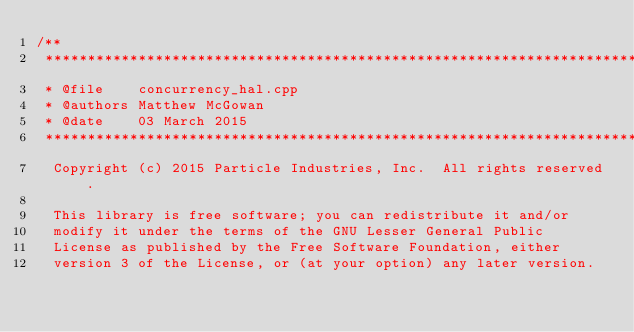<code> <loc_0><loc_0><loc_500><loc_500><_C++_>/**
 ******************************************************************************
 * @file    concurrency_hal.cpp
 * @authors Matthew McGowan
 * @date    03 March 2015
 ******************************************************************************
  Copyright (c) 2015 Particle Industries, Inc.  All rights reserved.

  This library is free software; you can redistribute it and/or
  modify it under the terms of the GNU Lesser General Public
  License as published by the Free Software Foundation, either
  version 3 of the License, or (at your option) any later version.
</code> 